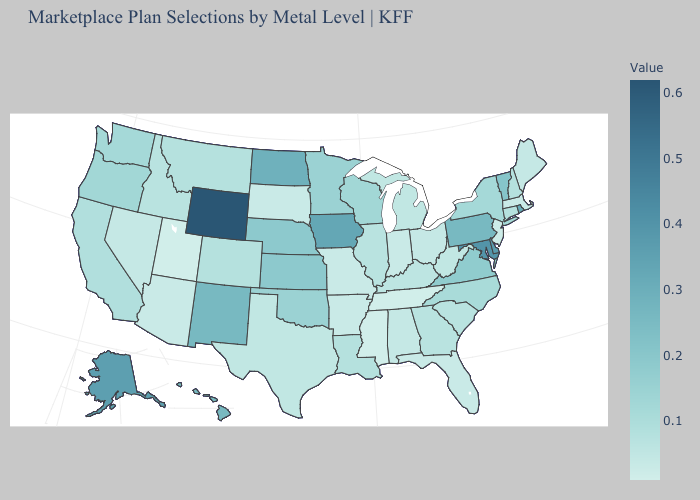Does Maine have the highest value in the USA?
Quick response, please. No. Does Vermont have a lower value than Alaska?
Write a very short answer. Yes. Does Mississippi have the lowest value in the USA?
Short answer required. Yes. Does Washington have a higher value than New Mexico?
Write a very short answer. No. 